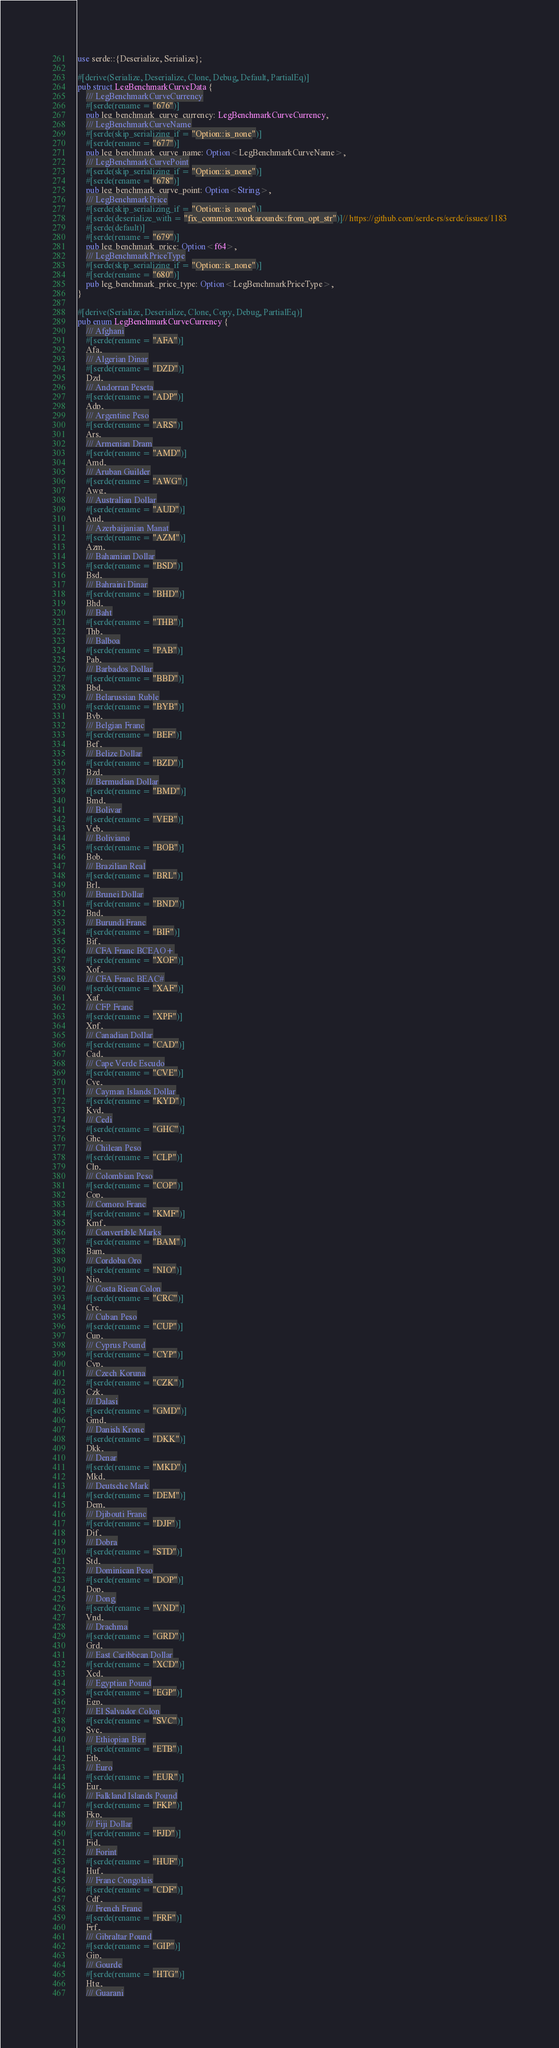Convert code to text. <code><loc_0><loc_0><loc_500><loc_500><_Rust_>
use serde::{Deserialize, Serialize};

#[derive(Serialize, Deserialize, Clone, Debug, Default, PartialEq)]
pub struct LegBenchmarkCurveData {
	/// LegBenchmarkCurveCurrency
	#[serde(rename = "676")]
	pub leg_benchmark_curve_currency: LegBenchmarkCurveCurrency,
	/// LegBenchmarkCurveName
	#[serde(skip_serializing_if = "Option::is_none")]
	#[serde(rename = "677")]
	pub leg_benchmark_curve_name: Option<LegBenchmarkCurveName>,
	/// LegBenchmarkCurvePoint
	#[serde(skip_serializing_if = "Option::is_none")]
	#[serde(rename = "678")]
	pub leg_benchmark_curve_point: Option<String>,
	/// LegBenchmarkPrice
	#[serde(skip_serializing_if = "Option::is_none")]
	#[serde(deserialize_with = "fix_common::workarounds::from_opt_str")]// https://github.com/serde-rs/serde/issues/1183
	#[serde(default)]
	#[serde(rename = "679")]
	pub leg_benchmark_price: Option<f64>,
	/// LegBenchmarkPriceType
	#[serde(skip_serializing_if = "Option::is_none")]
	#[serde(rename = "680")]
	pub leg_benchmark_price_type: Option<LegBenchmarkPriceType>,
}

#[derive(Serialize, Deserialize, Clone, Copy, Debug, PartialEq)]
pub enum LegBenchmarkCurveCurrency {
	/// Afghani
	#[serde(rename = "AFA")]
	Afa,
	/// Algerian Dinar
	#[serde(rename = "DZD")]
	Dzd,
	/// Andorran Peseta
	#[serde(rename = "ADP")]
	Adp,
	/// Argentine Peso
	#[serde(rename = "ARS")]
	Ars,
	/// Armenian Dram
	#[serde(rename = "AMD")]
	Amd,
	/// Aruban Guilder
	#[serde(rename = "AWG")]
	Awg,
	/// Australian Dollar
	#[serde(rename = "AUD")]
	Aud,
	/// Azerbaijanian Manat
	#[serde(rename = "AZM")]
	Azm,
	/// Bahamian Dollar
	#[serde(rename = "BSD")]
	Bsd,
	/// Bahraini Dinar
	#[serde(rename = "BHD")]
	Bhd,
	/// Baht
	#[serde(rename = "THB")]
	Thb,
	/// Balboa
	#[serde(rename = "PAB")]
	Pab,
	/// Barbados Dollar
	#[serde(rename = "BBD")]
	Bbd,
	/// Belarussian Ruble
	#[serde(rename = "BYB")]
	Byb,
	/// Belgian Franc
	#[serde(rename = "BEF")]
	Bef,
	/// Belize Dollar
	#[serde(rename = "BZD")]
	Bzd,
	/// Bermudian Dollar
	#[serde(rename = "BMD")]
	Bmd,
	/// Bolivar
	#[serde(rename = "VEB")]
	Veb,
	/// Boliviano
	#[serde(rename = "BOB")]
	Bob,
	/// Brazilian Real
	#[serde(rename = "BRL")]
	Brl,
	/// Brunei Dollar
	#[serde(rename = "BND")]
	Bnd,
	/// Burundi Franc
	#[serde(rename = "BIF")]
	Bif,
	/// CFA Franc BCEAO+
	#[serde(rename = "XOF")]
	Xof,
	/// CFA Franc BEAC#
	#[serde(rename = "XAF")]
	Xaf,
	/// CFP Franc
	#[serde(rename = "XPF")]
	Xpf,
	/// Canadian Dollar
	#[serde(rename = "CAD")]
	Cad,
	/// Cape Verde Escudo
	#[serde(rename = "CVE")]
	Cve,
	/// Cayman Islands Dollar
	#[serde(rename = "KYD")]
	Kyd,
	/// Cedi
	#[serde(rename = "GHC")]
	Ghc,
	/// Chilean Peso
	#[serde(rename = "CLP")]
	Clp,
	/// Colombian Peso
	#[serde(rename = "COP")]
	Cop,
	/// Comoro Franc
	#[serde(rename = "KMF")]
	Kmf,
	/// Convertible Marks
	#[serde(rename = "BAM")]
	Bam,
	/// Cordoba Oro
	#[serde(rename = "NIO")]
	Nio,
	/// Costa Rican Colon
	#[serde(rename = "CRC")]
	Crc,
	/// Cuban Peso
	#[serde(rename = "CUP")]
	Cup,
	/// Cyprus Pound
	#[serde(rename = "CYP")]
	Cyp,
	/// Czech Koruna
	#[serde(rename = "CZK")]
	Czk,
	/// Dalasi
	#[serde(rename = "GMD")]
	Gmd,
	/// Danish Krone
	#[serde(rename = "DKK")]
	Dkk,
	/// Denar
	#[serde(rename = "MKD")]
	Mkd,
	/// Deutsche Mark
	#[serde(rename = "DEM")]
	Dem,
	/// Djibouti Franc
	#[serde(rename = "DJF")]
	Djf,
	/// Dobra
	#[serde(rename = "STD")]
	Std,
	/// Dominican Peso
	#[serde(rename = "DOP")]
	Dop,
	/// Dong
	#[serde(rename = "VND")]
	Vnd,
	/// Drachma
	#[serde(rename = "GRD")]
	Grd,
	/// East Caribbean Dollar
	#[serde(rename = "XCD")]
	Xcd,
	/// Egyptian Pound
	#[serde(rename = "EGP")]
	Egp,
	/// El Salvador Colon
	#[serde(rename = "SVC")]
	Svc,
	/// Ethiopian Birr
	#[serde(rename = "ETB")]
	Etb,
	/// Euro
	#[serde(rename = "EUR")]
	Eur,
	/// Falkland Islands Pound
	#[serde(rename = "FKP")]
	Fkp,
	/// Fiji Dollar
	#[serde(rename = "FJD")]
	Fjd,
	/// Forint
	#[serde(rename = "HUF")]
	Huf,
	/// Franc Congolais
	#[serde(rename = "CDF")]
	Cdf,
	/// French Franc
	#[serde(rename = "FRF")]
	Frf,
	/// Gibraltar Pound
	#[serde(rename = "GIP")]
	Gip,
	/// Gourde
	#[serde(rename = "HTG")]
	Htg,
	/// Guarani</code> 